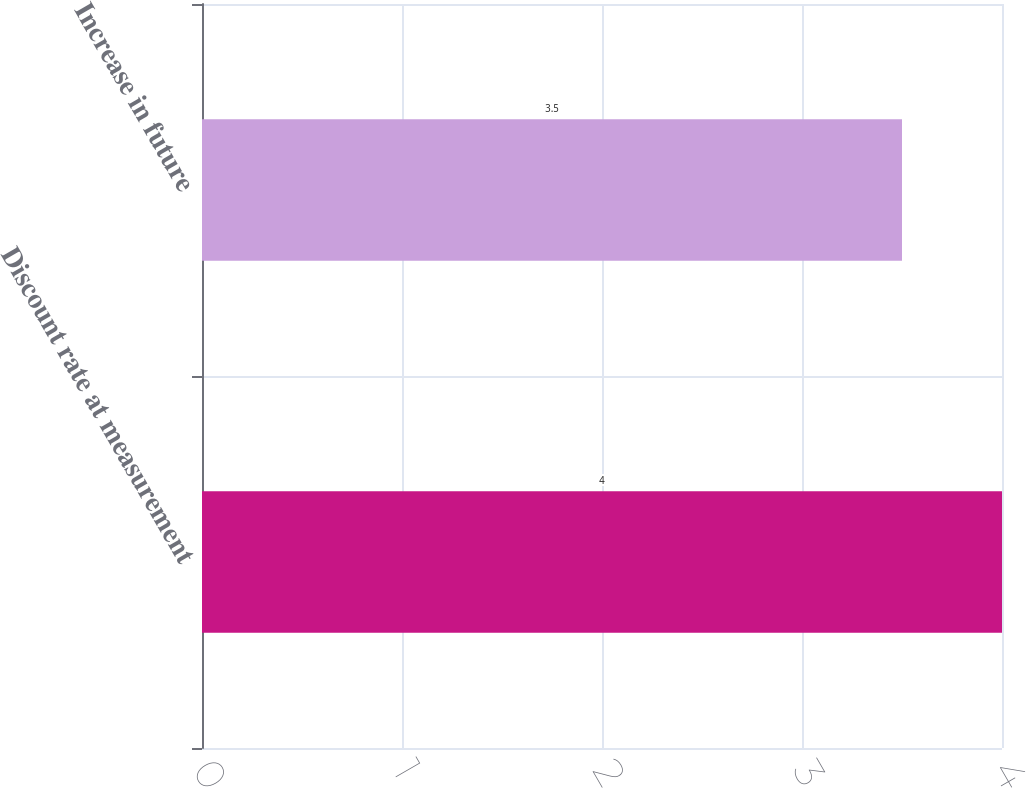Convert chart to OTSL. <chart><loc_0><loc_0><loc_500><loc_500><bar_chart><fcel>Discount rate at measurement<fcel>Increase in future<nl><fcel>4<fcel>3.5<nl></chart> 